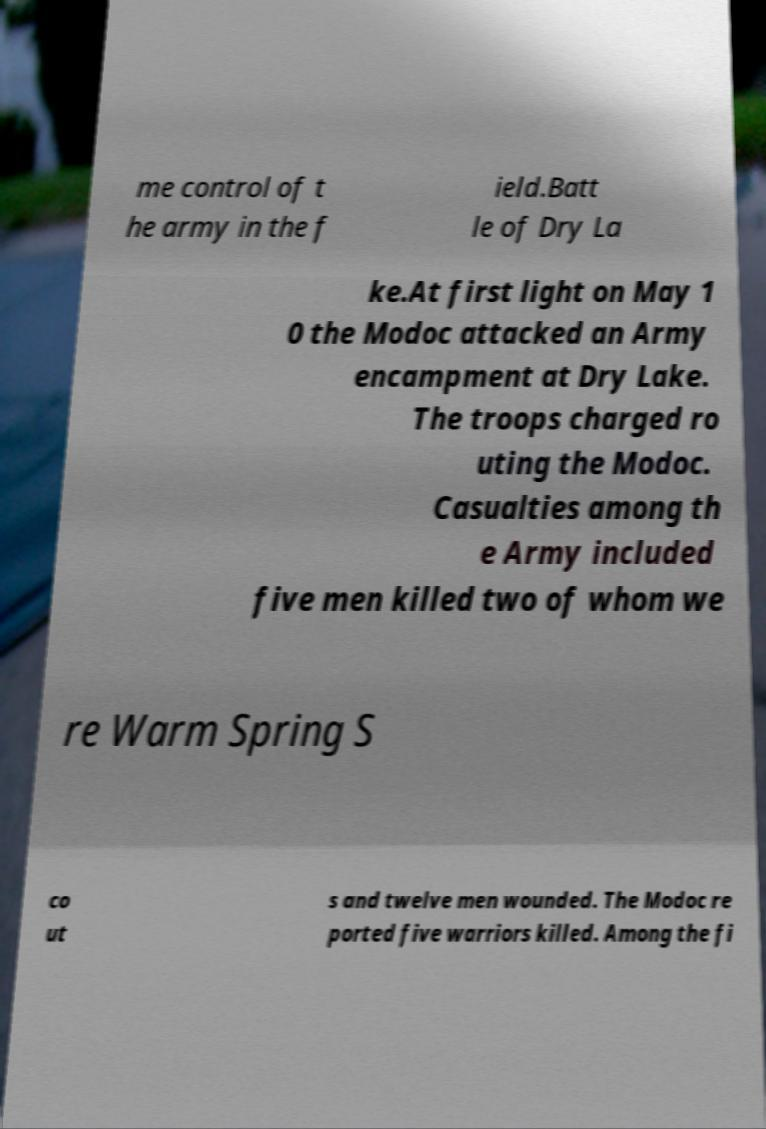I need the written content from this picture converted into text. Can you do that? me control of t he army in the f ield.Batt le of Dry La ke.At first light on May 1 0 the Modoc attacked an Army encampment at Dry Lake. The troops charged ro uting the Modoc. Casualties among th e Army included five men killed two of whom we re Warm Spring S co ut s and twelve men wounded. The Modoc re ported five warriors killed. Among the fi 